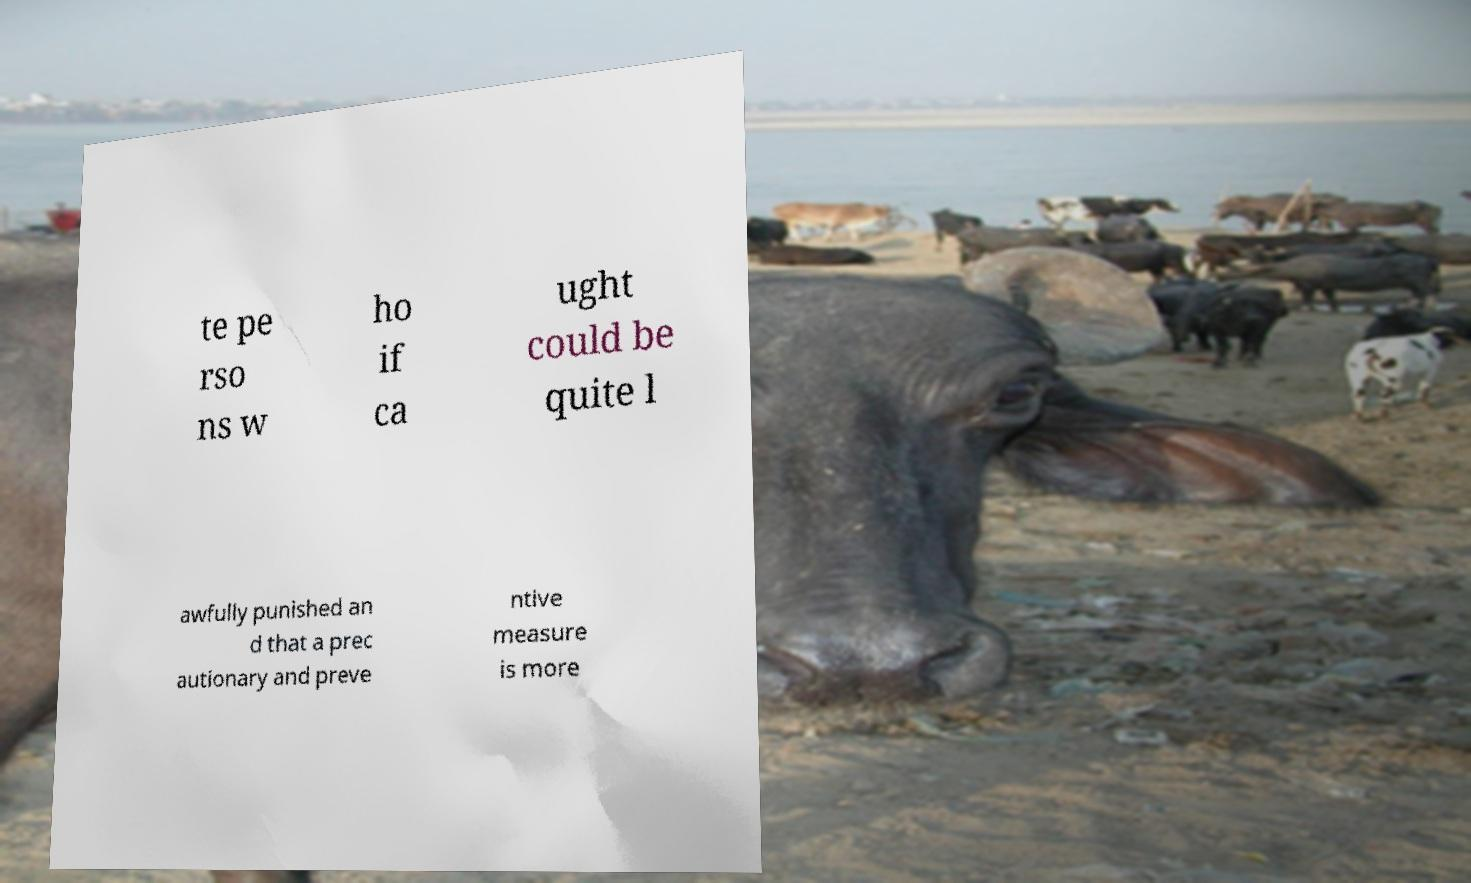I need the written content from this picture converted into text. Can you do that? te pe rso ns w ho if ca ught could be quite l awfully punished an d that a prec autionary and preve ntive measure is more 